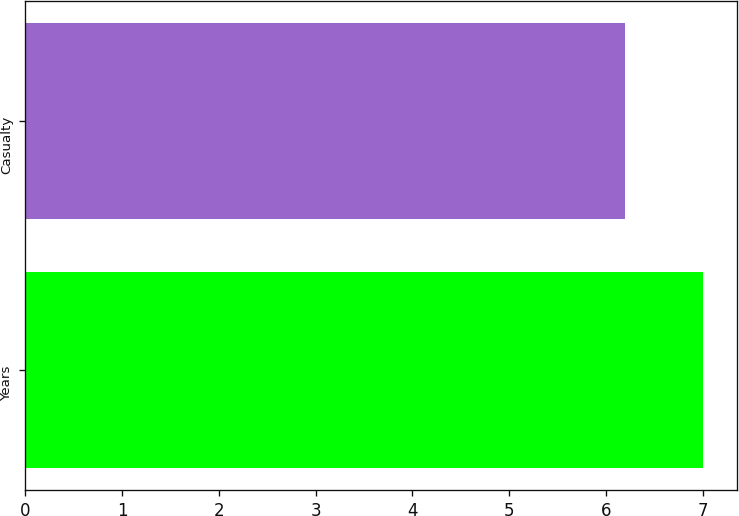<chart> <loc_0><loc_0><loc_500><loc_500><bar_chart><fcel>Years<fcel>Casualty<nl><fcel>7<fcel>6.2<nl></chart> 